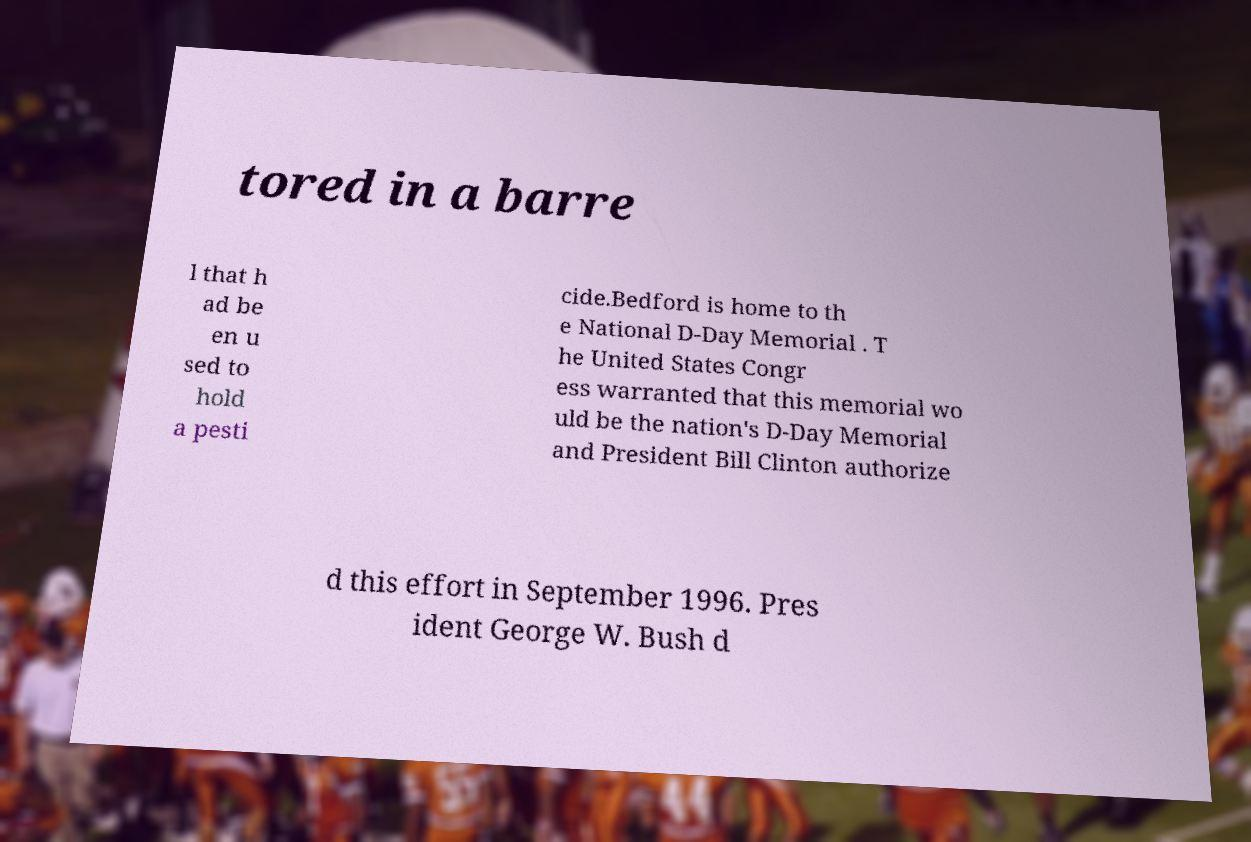What messages or text are displayed in this image? I need them in a readable, typed format. tored in a barre l that h ad be en u sed to hold a pesti cide.Bedford is home to th e National D-Day Memorial . T he United States Congr ess warranted that this memorial wo uld be the nation's D-Day Memorial and President Bill Clinton authorize d this effort in September 1996. Pres ident George W. Bush d 